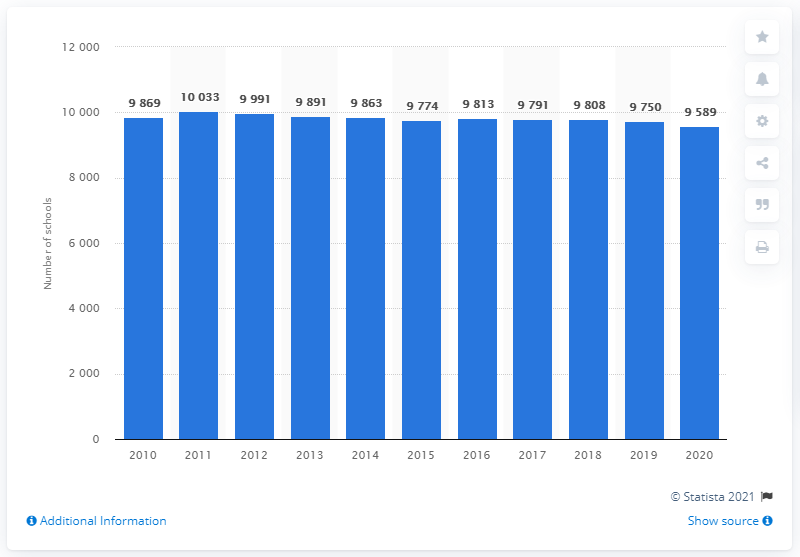Point out several critical features in this image. In 2011, Sweden had the highest number of preschools. In 2019, there were 9,869 preschools in Sweden. 